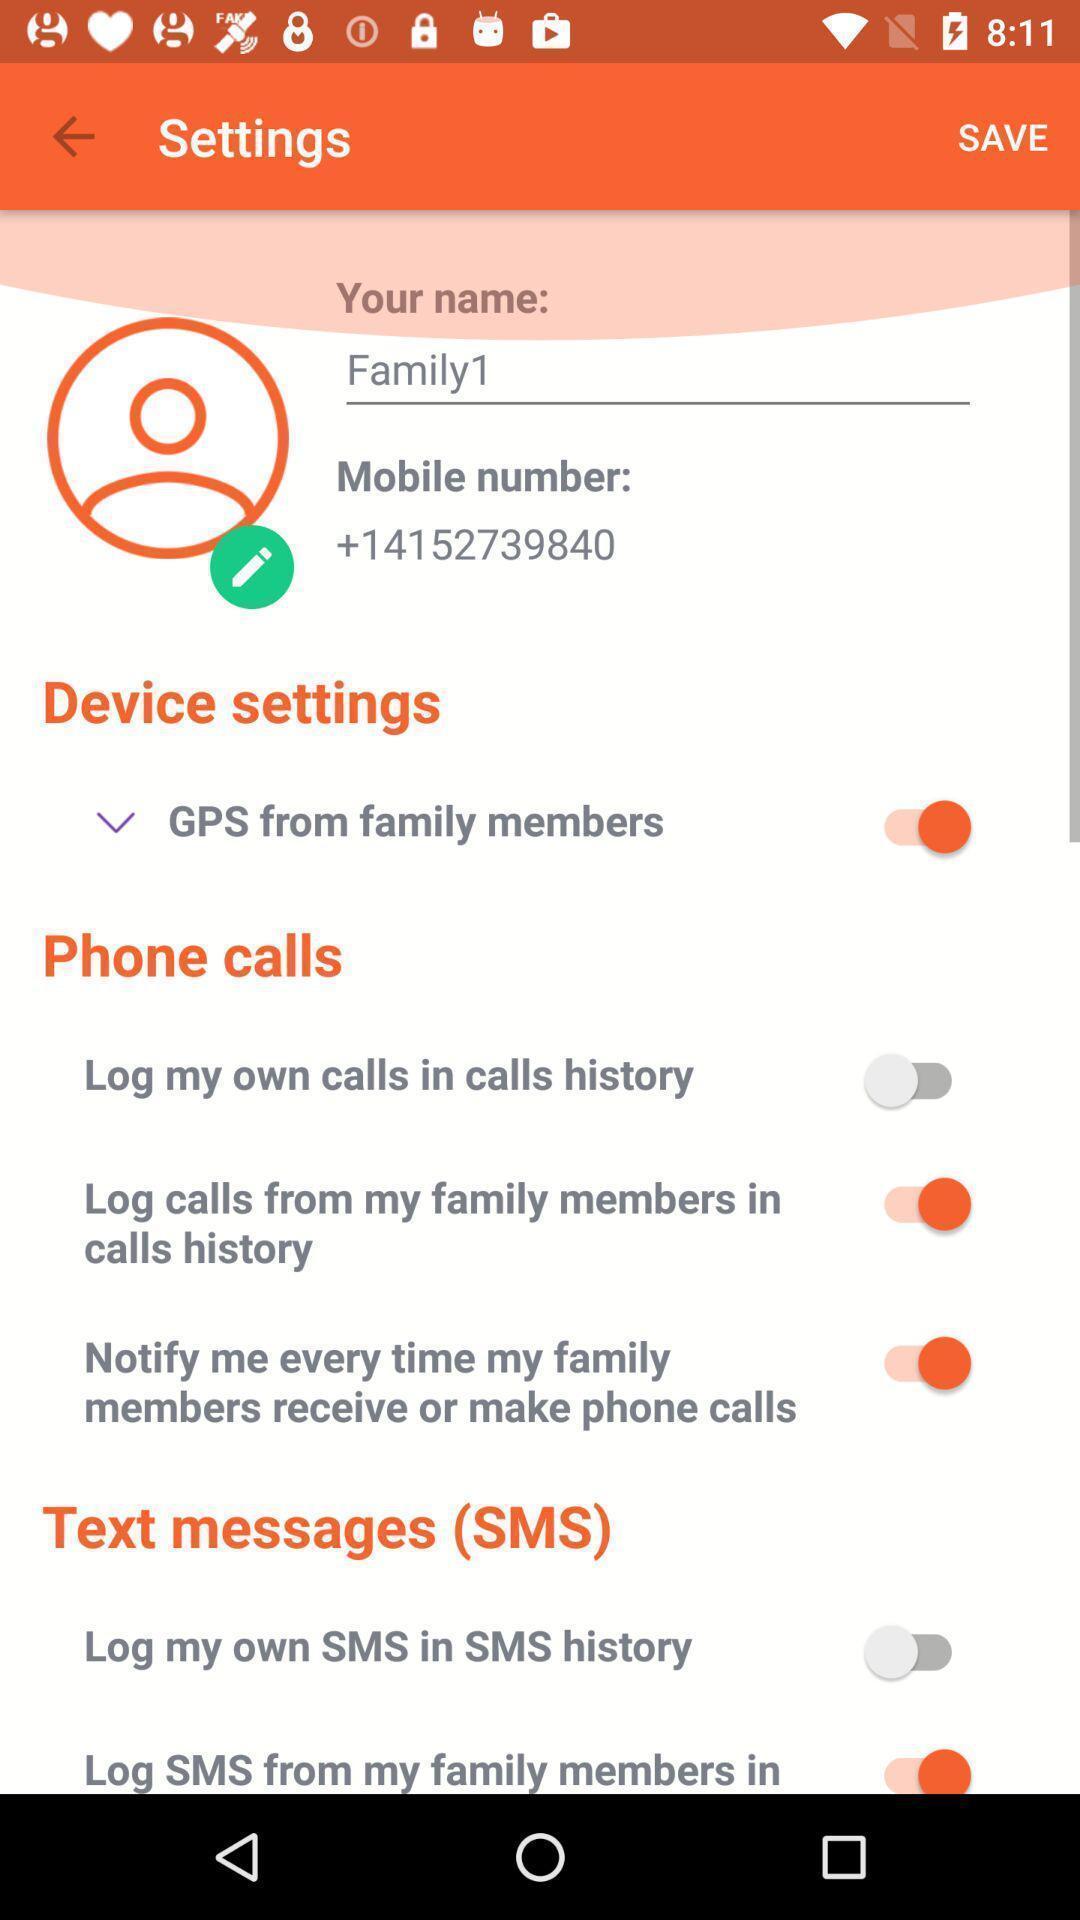Summarize the main components in this picture. Settings page displayed of a gps navigation app. 